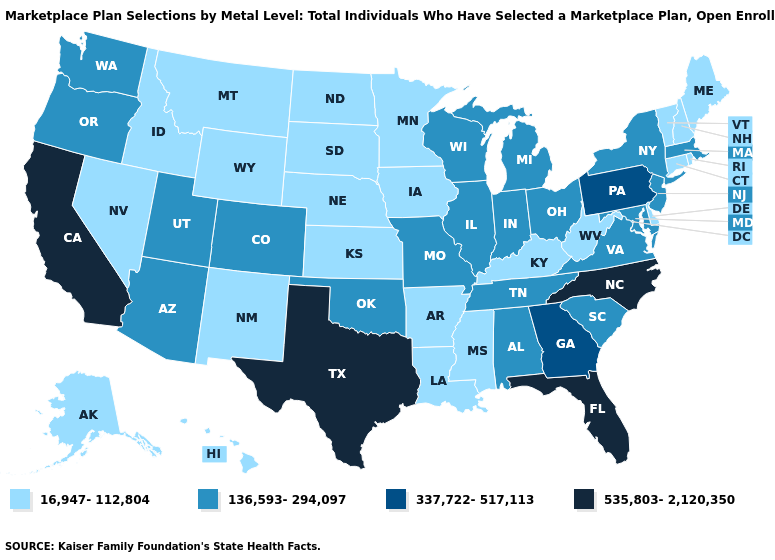Name the states that have a value in the range 337,722-517,113?
Short answer required. Georgia, Pennsylvania. What is the value of Connecticut?
Answer briefly. 16,947-112,804. What is the highest value in states that border Louisiana?
Keep it brief. 535,803-2,120,350. What is the value of Indiana?
Short answer required. 136,593-294,097. What is the highest value in states that border Rhode Island?
Give a very brief answer. 136,593-294,097. What is the value of New York?
Answer briefly. 136,593-294,097. Does the first symbol in the legend represent the smallest category?
Write a very short answer. Yes. Name the states that have a value in the range 337,722-517,113?
Answer briefly. Georgia, Pennsylvania. Name the states that have a value in the range 16,947-112,804?
Write a very short answer. Alaska, Arkansas, Connecticut, Delaware, Hawaii, Idaho, Iowa, Kansas, Kentucky, Louisiana, Maine, Minnesota, Mississippi, Montana, Nebraska, Nevada, New Hampshire, New Mexico, North Dakota, Rhode Island, South Dakota, Vermont, West Virginia, Wyoming. Name the states that have a value in the range 16,947-112,804?
Quick response, please. Alaska, Arkansas, Connecticut, Delaware, Hawaii, Idaho, Iowa, Kansas, Kentucky, Louisiana, Maine, Minnesota, Mississippi, Montana, Nebraska, Nevada, New Hampshire, New Mexico, North Dakota, Rhode Island, South Dakota, Vermont, West Virginia, Wyoming. Name the states that have a value in the range 337,722-517,113?
Concise answer only. Georgia, Pennsylvania. What is the value of Rhode Island?
Answer briefly. 16,947-112,804. How many symbols are there in the legend?
Short answer required. 4. Name the states that have a value in the range 136,593-294,097?
Short answer required. Alabama, Arizona, Colorado, Illinois, Indiana, Maryland, Massachusetts, Michigan, Missouri, New Jersey, New York, Ohio, Oklahoma, Oregon, South Carolina, Tennessee, Utah, Virginia, Washington, Wisconsin. 